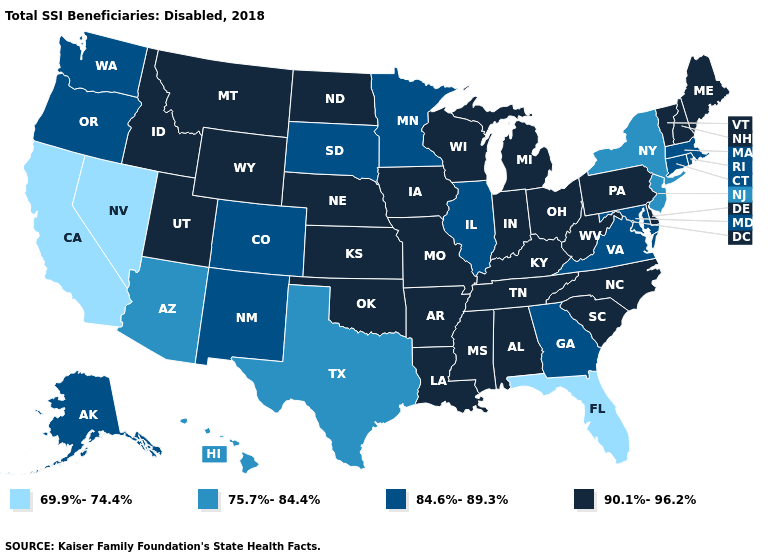What is the value of Mississippi?
Quick response, please. 90.1%-96.2%. What is the value of Indiana?
Write a very short answer. 90.1%-96.2%. What is the value of New Hampshire?
Concise answer only. 90.1%-96.2%. What is the value of Minnesota?
Give a very brief answer. 84.6%-89.3%. What is the value of Maine?
Answer briefly. 90.1%-96.2%. Does the first symbol in the legend represent the smallest category?
Concise answer only. Yes. What is the lowest value in states that border Utah?
Give a very brief answer. 69.9%-74.4%. Which states have the highest value in the USA?
Short answer required. Alabama, Arkansas, Delaware, Idaho, Indiana, Iowa, Kansas, Kentucky, Louisiana, Maine, Michigan, Mississippi, Missouri, Montana, Nebraska, New Hampshire, North Carolina, North Dakota, Ohio, Oklahoma, Pennsylvania, South Carolina, Tennessee, Utah, Vermont, West Virginia, Wisconsin, Wyoming. Name the states that have a value in the range 84.6%-89.3%?
Give a very brief answer. Alaska, Colorado, Connecticut, Georgia, Illinois, Maryland, Massachusetts, Minnesota, New Mexico, Oregon, Rhode Island, South Dakota, Virginia, Washington. Name the states that have a value in the range 75.7%-84.4%?
Be succinct. Arizona, Hawaii, New Jersey, New York, Texas. Does Iowa have the highest value in the USA?
Short answer required. Yes. Does Nevada have the highest value in the USA?
Quick response, please. No. What is the lowest value in the USA?
Answer briefly. 69.9%-74.4%. What is the value of South Dakota?
Write a very short answer. 84.6%-89.3%. 